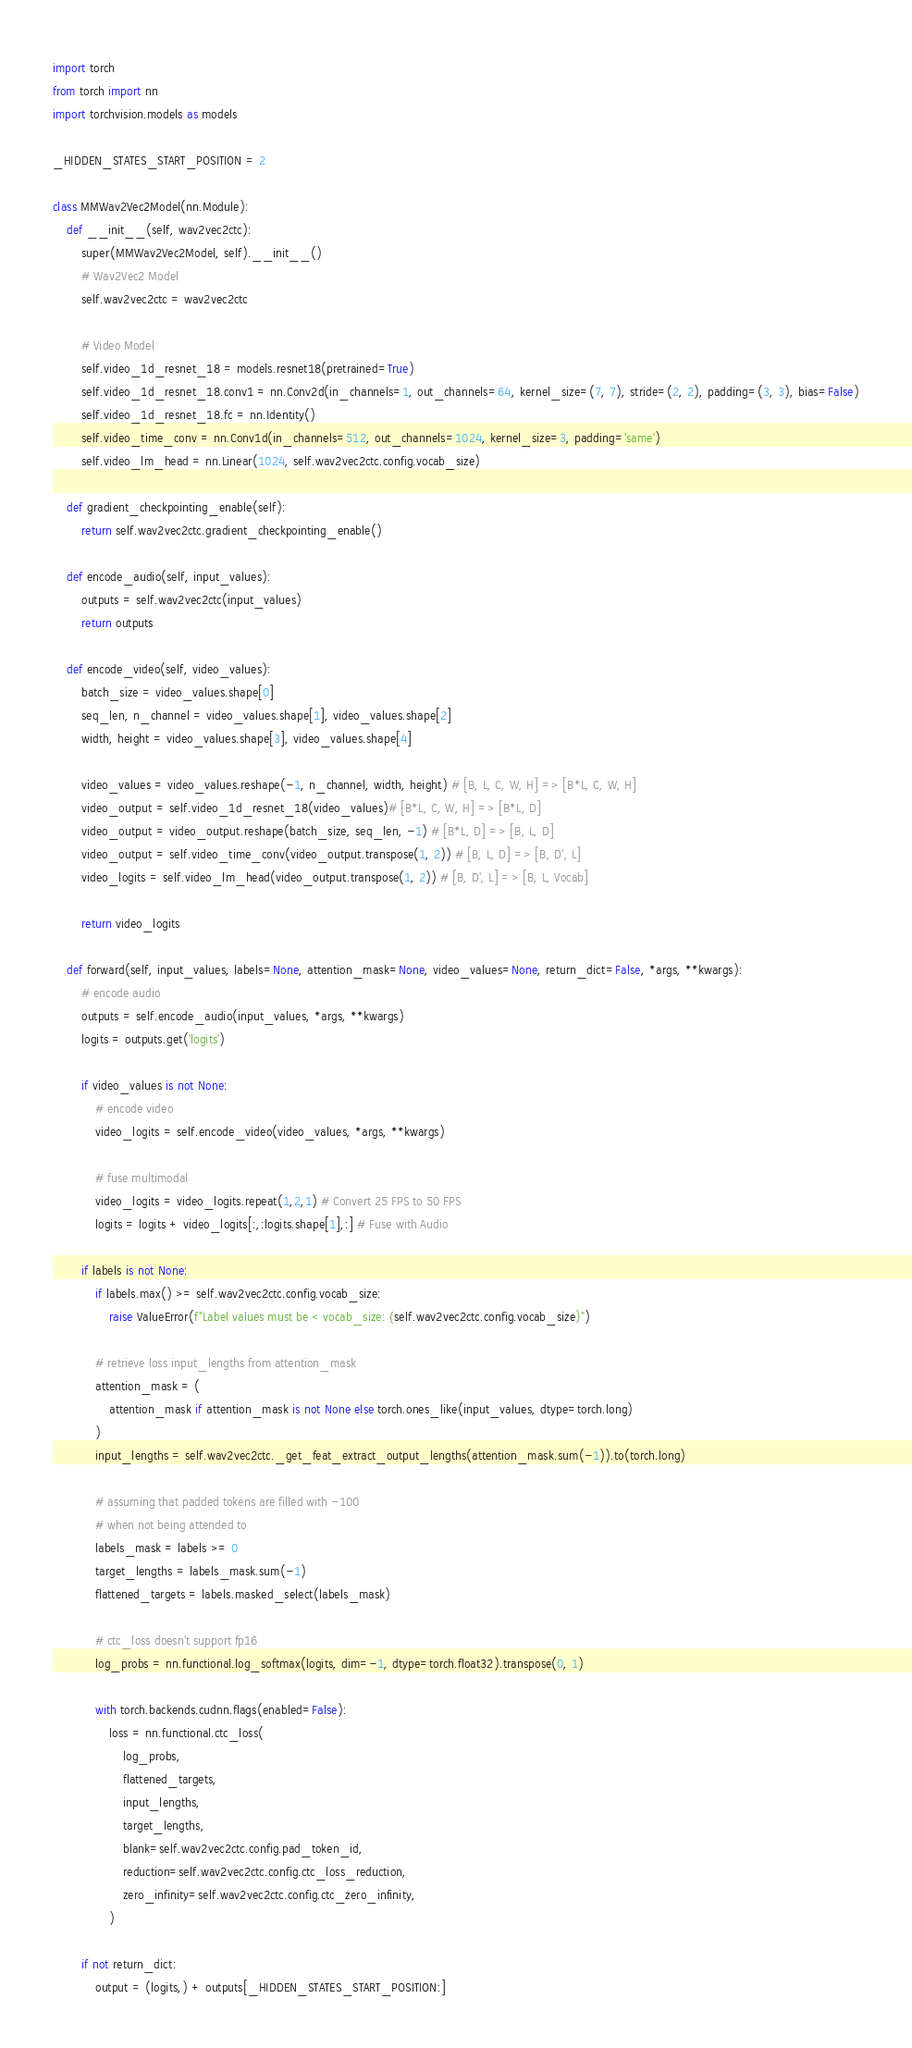<code> <loc_0><loc_0><loc_500><loc_500><_Python_>import torch
from torch import nn
import torchvision.models as models

_HIDDEN_STATES_START_POSITION = 2

class MMWav2Vec2Model(nn.Module):
    def __init__(self, wav2vec2ctc):
        super(MMWav2Vec2Model, self).__init__()
        # Wav2Vec2 Model
        self.wav2vec2ctc = wav2vec2ctc
        
        # Video Model
        self.video_1d_resnet_18 = models.resnet18(pretrained=True)
        self.video_1d_resnet_18.conv1 = nn.Conv2d(in_channels=1, out_channels=64, kernel_size=(7, 7), stride=(2, 2), padding=(3, 3), bias=False)
        self.video_1d_resnet_18.fc = nn.Identity()
        self.video_time_conv = nn.Conv1d(in_channels=512, out_channels=1024, kernel_size=3, padding='same')
        self.video_lm_head = nn.Linear(1024, self.wav2vec2ctc.config.vocab_size)
        
    def gradient_checkpointing_enable(self):
        return self.wav2vec2ctc.gradient_checkpointing_enable()
    
    def encode_audio(self, input_values):
        outputs = self.wav2vec2ctc(input_values)
        return outputs
        
    def encode_video(self, video_values):
        batch_size = video_values.shape[0]
        seq_len, n_channel = video_values.shape[1], video_values.shape[2]
        width, height = video_values.shape[3], video_values.shape[4]

        video_values = video_values.reshape(-1, n_channel, width, height) # [B, L, C, W, H] => [B*L, C, W, H]
        video_output = self.video_1d_resnet_18(video_values)# [B*L, C, W, H] => [B*L, D]
        video_output = video_output.reshape(batch_size, seq_len, -1) # [B*L, D] => [B, L, D]
        video_output = self.video_time_conv(video_output.transpose(1, 2)) # [B, L, D] => [B, D', L]
        video_logits = self.video_lm_head(video_output.transpose(1, 2)) # [B, D', L] => [B, L, Vocab]
        
        return video_logits

    def forward(self, input_values, labels=None, attention_mask=None, video_values=None, return_dict=False, *args, **kwargs):
        # encode audio
        outputs = self.encode_audio(input_values, *args, **kwargs)
        logits = outputs.get('logits')
        
        if video_values is not None:
            # encode video
            video_logits = self.encode_video(video_values, *args, **kwargs)
            
            # fuse multimodal
            video_logits = video_logits.repeat(1,2,1) # Convert 25 FPS to 50 FPS
            logits = logits + video_logits[:,:logits.shape[1],:] # Fuse with Audio

        if labels is not None:
            if labels.max() >= self.wav2vec2ctc.config.vocab_size:
                raise ValueError(f"Label values must be < vocab_size: {self.wav2vec2ctc.config.vocab_size}")

            # retrieve loss input_lengths from attention_mask
            attention_mask = (
                attention_mask if attention_mask is not None else torch.ones_like(input_values, dtype=torch.long)
            )
            input_lengths = self.wav2vec2ctc._get_feat_extract_output_lengths(attention_mask.sum(-1)).to(torch.long)

            # assuming that padded tokens are filled with -100
            # when not being attended to
            labels_mask = labels >= 0
            target_lengths = labels_mask.sum(-1)
            flattened_targets = labels.masked_select(labels_mask)

            # ctc_loss doesn't support fp16
            log_probs = nn.functional.log_softmax(logits, dim=-1, dtype=torch.float32).transpose(0, 1)

            with torch.backends.cudnn.flags(enabled=False):
                loss = nn.functional.ctc_loss(
                    log_probs,
                    flattened_targets,
                    input_lengths,
                    target_lengths,
                    blank=self.wav2vec2ctc.config.pad_token_id,
                    reduction=self.wav2vec2ctc.config.ctc_loss_reduction,
                    zero_infinity=self.wav2vec2ctc.config.ctc_zero_infinity,
                )

        if not return_dict:
            output = (logits,) + outputs[_HIDDEN_STATES_START_POSITION:]</code> 